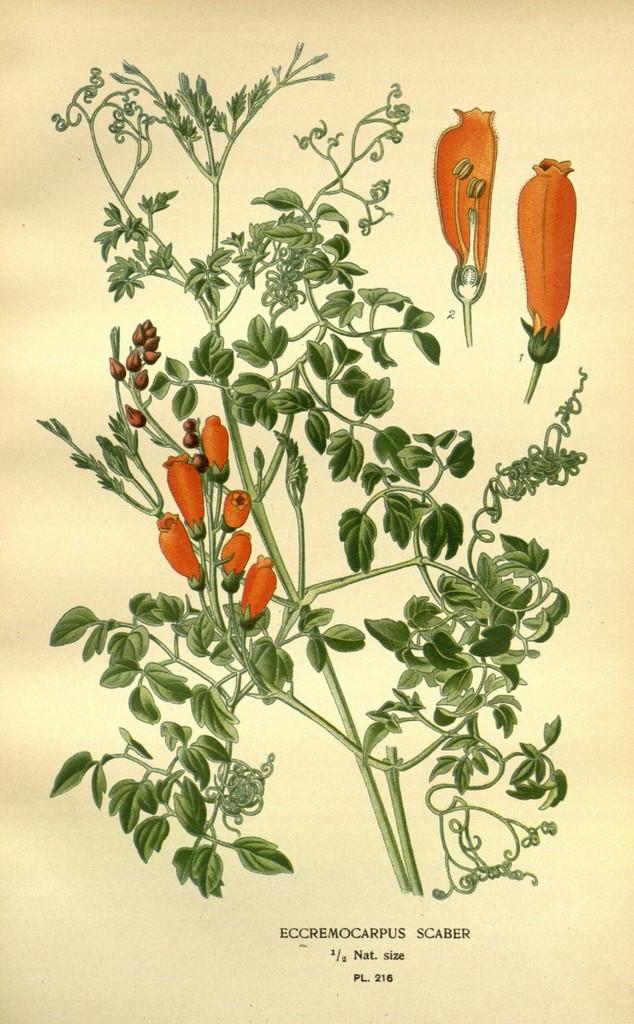What is present in the picture? There is a plant in the picture. What color can be observed on the plant? The plant has orange coloring. Is there any text associated with the plant in the image? Yes, there is text written below the plant. What type of stick can be seen in the mouth of the plant in the image? There is no stick or mouth present in the image; it features a plant with orange coloring and text below it. 